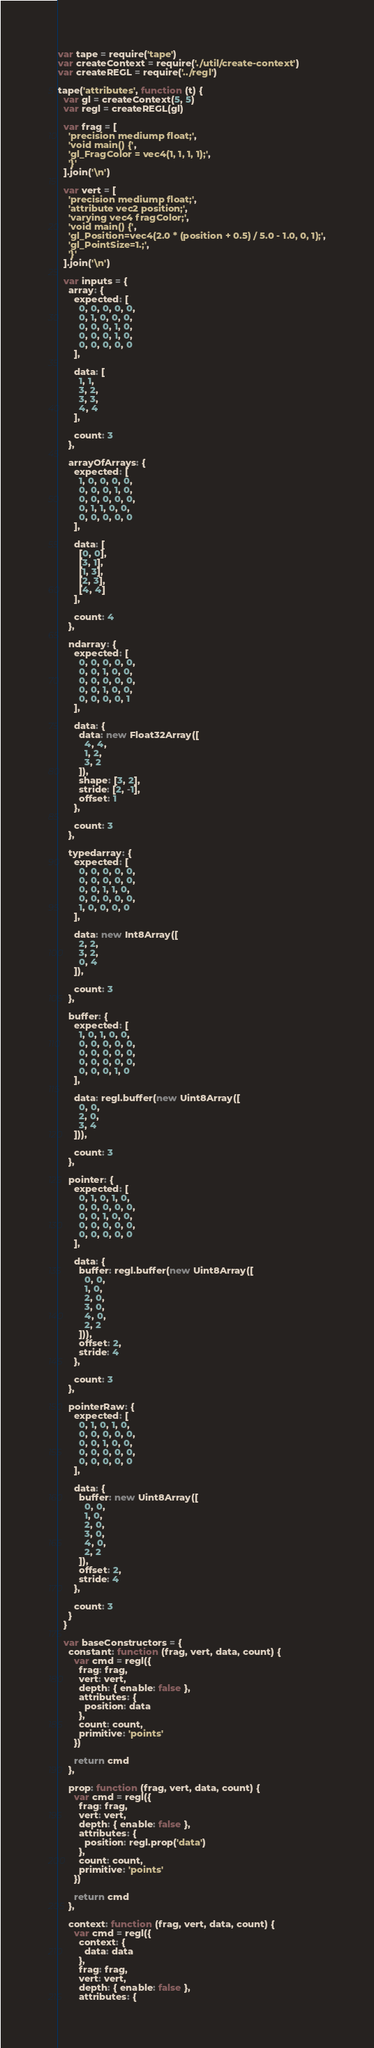Convert code to text. <code><loc_0><loc_0><loc_500><loc_500><_JavaScript_>var tape = require('tape')
var createContext = require('./util/create-context')
var createREGL = require('../regl')

tape('attributes', function (t) {
  var gl = createContext(5, 5)
  var regl = createREGL(gl)

  var frag = [
    'precision mediump float;',
    'void main() {',
    'gl_FragColor = vec4(1, 1, 1, 1);',
    '}'
  ].join('\n')

  var vert = [
    'precision mediump float;',
    'attribute vec2 position;',
    'varying vec4 fragColor;',
    'void main() {',
    'gl_Position=vec4(2.0 * (position + 0.5) / 5.0 - 1.0, 0, 1);',
    'gl_PointSize=1.;',
    '}'
  ].join('\n')

  var inputs = {
    array: {
      expected: [
        0, 0, 0, 0, 0,
        0, 1, 0, 0, 0,
        0, 0, 0, 1, 0,
        0, 0, 0, 1, 0,
        0, 0, 0, 0, 0
      ],

      data: [
        1, 1,
        3, 2,
        3, 3,
        4, 4
      ],

      count: 3
    },

    arrayOfArrays: {
      expected: [
        1, 0, 0, 0, 0,
        0, 0, 0, 1, 0,
        0, 0, 0, 0, 0,
        0, 1, 1, 0, 0,
        0, 0, 0, 0, 0
      ],

      data: [
        [0, 0],
        [3, 1],
        [1, 3],
        [2, 3],
        [4, 4]
      ],

      count: 4
    },

    ndarray: {
      expected: [
        0, 0, 0, 0, 0,
        0, 0, 1, 0, 0,
        0, 0, 0, 0, 0,
        0, 0, 1, 0, 0,
        0, 0, 0, 0, 1
      ],

      data: {
        data: new Float32Array([
          4, 4,
          1, 2,
          3, 2
        ]),
        shape: [3, 2],
        stride: [2, -1],
        offset: 1
      },

      count: 3
    },

    typedarray: {
      expected: [
        0, 0, 0, 0, 0,
        0, 0, 0, 0, 0,
        0, 0, 1, 1, 0,
        0, 0, 0, 0, 0,
        1, 0, 0, 0, 0
      ],

      data: new Int8Array([
        2, 2,
        3, 2,
        0, 4
      ]),

      count: 3
    },

    buffer: {
      expected: [
        1, 0, 1, 0, 0,
        0, 0, 0, 0, 0,
        0, 0, 0, 0, 0,
        0, 0, 0, 0, 0,
        0, 0, 0, 1, 0
      ],

      data: regl.buffer(new Uint8Array([
        0, 0,
        2, 0,
        3, 4
      ])),

      count: 3
    },

    pointer: {
      expected: [
        0, 1, 0, 1, 0,
        0, 0, 0, 0, 0,
        0, 0, 1, 0, 0,
        0, 0, 0, 0, 0,
        0, 0, 0, 0, 0
      ],

      data: {
        buffer: regl.buffer(new Uint8Array([
          0, 0,
          1, 0,
          2, 0,
          3, 0,
          4, 0,
          2, 2
        ])),
        offset: 2,
        stride: 4
      },

      count: 3
    },

    pointerRaw: {
      expected: [
        0, 1, 0, 1, 0,
        0, 0, 0, 0, 0,
        0, 0, 1, 0, 0,
        0, 0, 0, 0, 0,
        0, 0, 0, 0, 0
      ],

      data: {
        buffer: new Uint8Array([
          0, 0,
          1, 0,
          2, 0,
          3, 0,
          4, 0,
          2, 2
        ]),
        offset: 2,
        stride: 4
      },

      count: 3
    }
  }

  var baseConstructors = {
    constant: function (frag, vert, data, count) {
      var cmd = regl({
        frag: frag,
        vert: vert,
        depth: { enable: false },
        attributes: {
          position: data
        },
        count: count,
        primitive: 'points'
      })

      return cmd
    },

    prop: function (frag, vert, data, count) {
      var cmd = regl({
        frag: frag,
        vert: vert,
        depth: { enable: false },
        attributes: {
          position: regl.prop('data')
        },
        count: count,
        primitive: 'points'
      })

      return cmd
    },

    context: function (frag, vert, data, count) {
      var cmd = regl({
        context: {
          data: data
        },
        frag: frag,
        vert: vert,
        depth: { enable: false },
        attributes: {</code> 